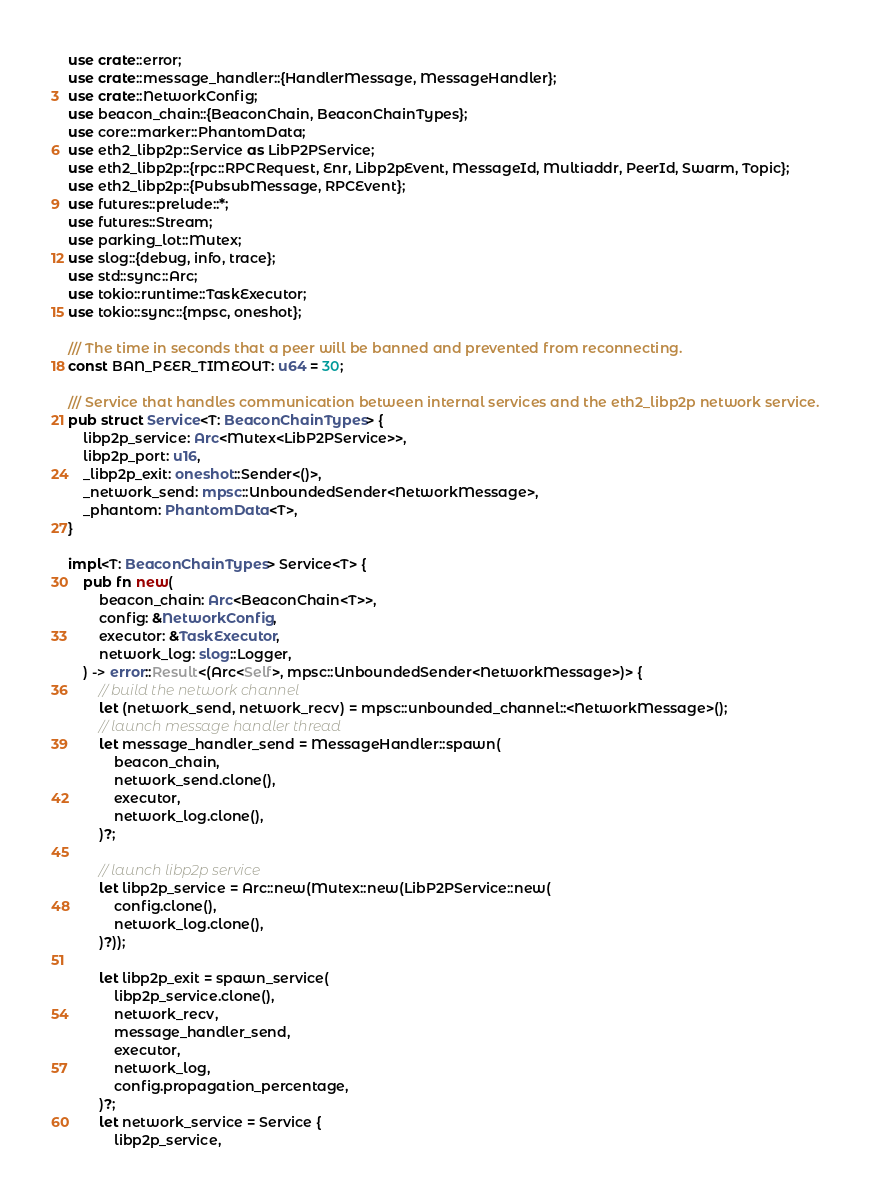<code> <loc_0><loc_0><loc_500><loc_500><_Rust_>use crate::error;
use crate::message_handler::{HandlerMessage, MessageHandler};
use crate::NetworkConfig;
use beacon_chain::{BeaconChain, BeaconChainTypes};
use core::marker::PhantomData;
use eth2_libp2p::Service as LibP2PService;
use eth2_libp2p::{rpc::RPCRequest, Enr, Libp2pEvent, MessageId, Multiaddr, PeerId, Swarm, Topic};
use eth2_libp2p::{PubsubMessage, RPCEvent};
use futures::prelude::*;
use futures::Stream;
use parking_lot::Mutex;
use slog::{debug, info, trace};
use std::sync::Arc;
use tokio::runtime::TaskExecutor;
use tokio::sync::{mpsc, oneshot};

/// The time in seconds that a peer will be banned and prevented from reconnecting.
const BAN_PEER_TIMEOUT: u64 = 30;

/// Service that handles communication between internal services and the eth2_libp2p network service.
pub struct Service<T: BeaconChainTypes> {
    libp2p_service: Arc<Mutex<LibP2PService>>,
    libp2p_port: u16,
    _libp2p_exit: oneshot::Sender<()>,
    _network_send: mpsc::UnboundedSender<NetworkMessage>,
    _phantom: PhantomData<T>,
}

impl<T: BeaconChainTypes> Service<T> {
    pub fn new(
        beacon_chain: Arc<BeaconChain<T>>,
        config: &NetworkConfig,
        executor: &TaskExecutor,
        network_log: slog::Logger,
    ) -> error::Result<(Arc<Self>, mpsc::UnboundedSender<NetworkMessage>)> {
        // build the network channel
        let (network_send, network_recv) = mpsc::unbounded_channel::<NetworkMessage>();
        // launch message handler thread
        let message_handler_send = MessageHandler::spawn(
            beacon_chain,
            network_send.clone(),
            executor,
            network_log.clone(),
        )?;

        // launch libp2p service
        let libp2p_service = Arc::new(Mutex::new(LibP2PService::new(
            config.clone(),
            network_log.clone(),
        )?));

        let libp2p_exit = spawn_service(
            libp2p_service.clone(),
            network_recv,
            message_handler_send,
            executor,
            network_log,
            config.propagation_percentage,
        )?;
        let network_service = Service {
            libp2p_service,</code> 